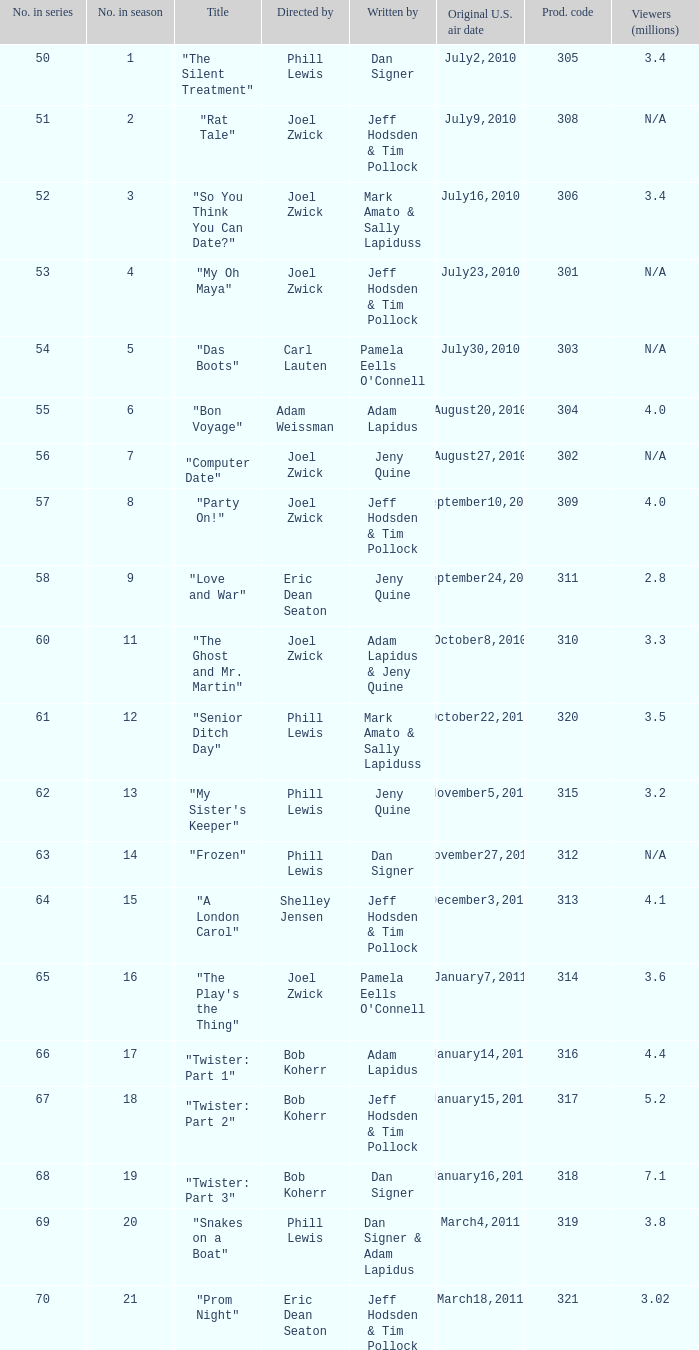How many million viewers watched episode 6? 4.0. 